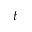<formula> <loc_0><loc_0><loc_500><loc_500>t</formula> 